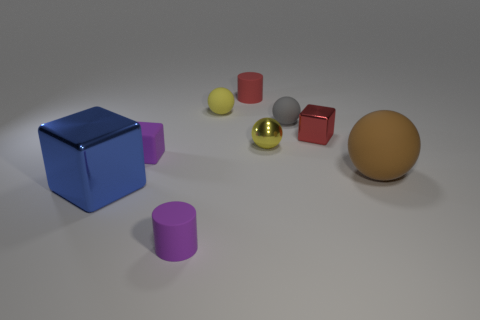Subtract all tiny cubes. How many cubes are left? 1 Subtract all small red objects. Subtract all small metallic cubes. How many objects are left? 6 Add 5 big blue cubes. How many big blue cubes are left? 6 Add 1 matte objects. How many matte objects exist? 7 Subtract all brown balls. How many balls are left? 3 Subtract 0 purple spheres. How many objects are left? 9 Subtract all balls. How many objects are left? 5 Subtract 2 spheres. How many spheres are left? 2 Subtract all purple cylinders. Subtract all blue spheres. How many cylinders are left? 1 Subtract all yellow cylinders. How many gray balls are left? 1 